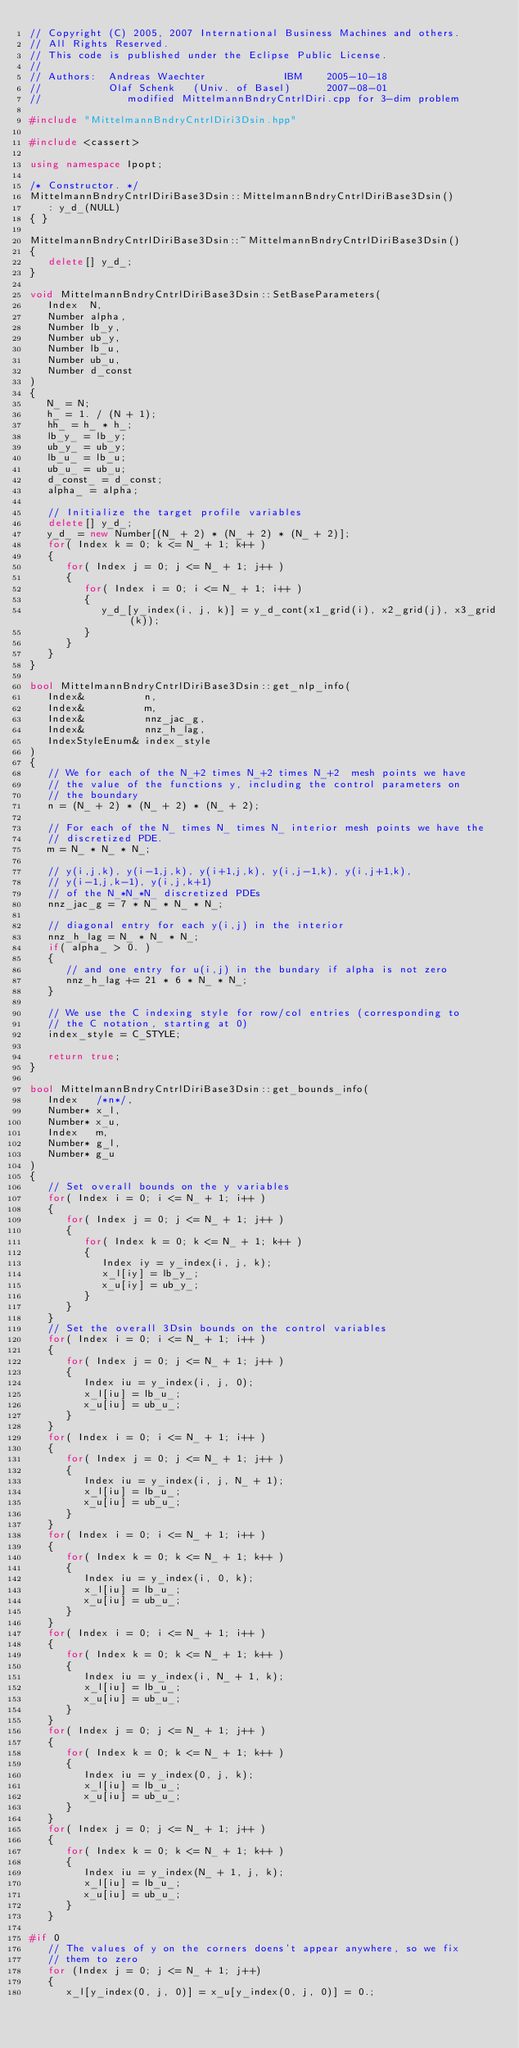<code> <loc_0><loc_0><loc_500><loc_500><_C++_>// Copyright (C) 2005, 2007 International Business Machines and others.
// All Rights Reserved.
// This code is published under the Eclipse Public License.
//
// Authors:  Andreas Waechter             IBM    2005-10-18
//           Olaf Schenk   (Univ. of Basel)      2007-08-01
//              modified MittelmannBndryCntrlDiri.cpp for 3-dim problem

#include "MittelmannBndryCntrlDiri3Dsin.hpp"

#include <cassert>

using namespace Ipopt;

/* Constructor. */
MittelmannBndryCntrlDiriBase3Dsin::MittelmannBndryCntrlDiriBase3Dsin()
   : y_d_(NULL)
{ }

MittelmannBndryCntrlDiriBase3Dsin::~MittelmannBndryCntrlDiriBase3Dsin()
{
   delete[] y_d_;
}

void MittelmannBndryCntrlDiriBase3Dsin::SetBaseParameters(
   Index  N,
   Number alpha,
   Number lb_y,
   Number ub_y,
   Number lb_u,
   Number ub_u,
   Number d_const
)
{
   N_ = N;
   h_ = 1. / (N + 1);
   hh_ = h_ * h_;
   lb_y_ = lb_y;
   ub_y_ = ub_y;
   lb_u_ = lb_u;
   ub_u_ = ub_u;
   d_const_ = d_const;
   alpha_ = alpha;

   // Initialize the target profile variables
   delete[] y_d_;
   y_d_ = new Number[(N_ + 2) * (N_ + 2) * (N_ + 2)];
   for( Index k = 0; k <= N_ + 1; k++ )
   {
      for( Index j = 0; j <= N_ + 1; j++ )
      {
         for( Index i = 0; i <= N_ + 1; i++ )
         {
            y_d_[y_index(i, j, k)] = y_d_cont(x1_grid(i), x2_grid(j), x3_grid(k));
         }
      }
   }
}

bool MittelmannBndryCntrlDiriBase3Dsin::get_nlp_info(
   Index&          n,
   Index&          m,
   Index&          nnz_jac_g,
   Index&          nnz_h_lag,
   IndexStyleEnum& index_style
)
{
   // We for each of the N_+2 times N_+2 times N_+2  mesh points we have
   // the value of the functions y, including the control parameters on
   // the boundary
   n = (N_ + 2) * (N_ + 2) * (N_ + 2);

   // For each of the N_ times N_ times N_ interior mesh points we have the
   // discretized PDE.
   m = N_ * N_ * N_;

   // y(i,j,k), y(i-1,j,k), y(i+1,j,k), y(i,j-1,k), y(i,j+1,k),
   // y(i-1,j,k-1), y(i,j,k+1)
   // of the N_*N_*N_ discretized PDEs
   nnz_jac_g = 7 * N_ * N_ * N_;

   // diagonal entry for each y(i,j) in the interior
   nnz_h_lag = N_ * N_ * N_;
   if( alpha_ > 0. )
   {
      // and one entry for u(i,j) in the bundary if alpha is not zero
      nnz_h_lag += 21 * 6 * N_ * N_;
   }

   // We use the C indexing style for row/col entries (corresponding to
   // the C notation, starting at 0)
   index_style = C_STYLE;

   return true;
}

bool MittelmannBndryCntrlDiriBase3Dsin::get_bounds_info(
   Index   /*n*/,
   Number* x_l,
   Number* x_u,
   Index   m,
   Number* g_l,
   Number* g_u
)
{
   // Set overall bounds on the y variables
   for( Index i = 0; i <= N_ + 1; i++ )
   {
      for( Index j = 0; j <= N_ + 1; j++ )
      {
         for( Index k = 0; k <= N_ + 1; k++ )
         {
            Index iy = y_index(i, j, k);
            x_l[iy] = lb_y_;
            x_u[iy] = ub_y_;
         }
      }
   }
   // Set the overall 3Dsin bounds on the control variables
   for( Index i = 0; i <= N_ + 1; i++ )
   {
      for( Index j = 0; j <= N_ + 1; j++ )
      {
         Index iu = y_index(i, j, 0);
         x_l[iu] = lb_u_;
         x_u[iu] = ub_u_;
      }
   }
   for( Index i = 0; i <= N_ + 1; i++ )
   {
      for( Index j = 0; j <= N_ + 1; j++ )
      {
         Index iu = y_index(i, j, N_ + 1);
         x_l[iu] = lb_u_;
         x_u[iu] = ub_u_;
      }
   }
   for( Index i = 0; i <= N_ + 1; i++ )
   {
      for( Index k = 0; k <= N_ + 1; k++ )
      {
         Index iu = y_index(i, 0, k);
         x_l[iu] = lb_u_;
         x_u[iu] = ub_u_;
      }
   }
   for( Index i = 0; i <= N_ + 1; i++ )
   {
      for( Index k = 0; k <= N_ + 1; k++ )
      {
         Index iu = y_index(i, N_ + 1, k);
         x_l[iu] = lb_u_;
         x_u[iu] = ub_u_;
      }
   }
   for( Index j = 0; j <= N_ + 1; j++ )
   {
      for( Index k = 0; k <= N_ + 1; k++ )
      {
         Index iu = y_index(0, j, k);
         x_l[iu] = lb_u_;
         x_u[iu] = ub_u_;
      }
   }
   for( Index j = 0; j <= N_ + 1; j++ )
   {
      for( Index k = 0; k <= N_ + 1; k++ )
      {
         Index iu = y_index(N_ + 1, j, k);
         x_l[iu] = lb_u_;
         x_u[iu] = ub_u_;
      }
   }

#if 0
   // The values of y on the corners doens't appear anywhere, so we fix
   // them to zero
   for (Index j = 0; j <= N_ + 1; j++)
   {
      x_l[y_index(0, j, 0)] = x_u[y_index(0, j, 0)] = 0.;</code> 